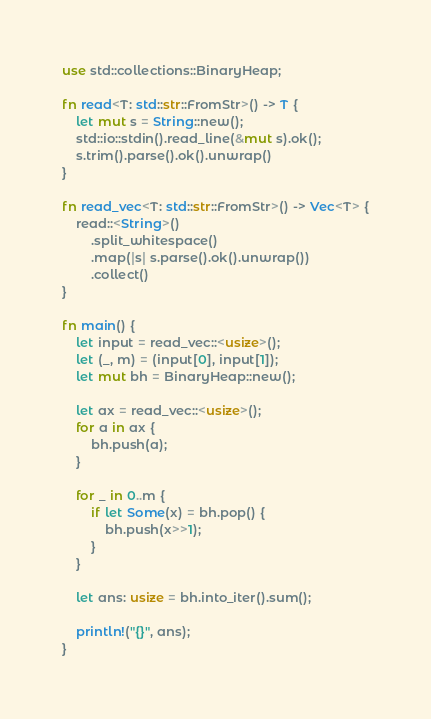<code> <loc_0><loc_0><loc_500><loc_500><_Rust_>use std::collections::BinaryHeap;

fn read<T: std::str::FromStr>() -> T {
    let mut s = String::new();
    std::io::stdin().read_line(&mut s).ok();
    s.trim().parse().ok().unwrap()
}

fn read_vec<T: std::str::FromStr>() -> Vec<T> {
    read::<String>()
        .split_whitespace()
        .map(|s| s.parse().ok().unwrap())
        .collect()
}

fn main() {
    let input = read_vec::<usize>();
    let (_, m) = (input[0], input[1]);
    let mut bh = BinaryHeap::new();

    let ax = read_vec::<usize>();
    for a in ax {
        bh.push(a);
    }

    for _ in 0..m {
        if let Some(x) = bh.pop() {
            bh.push(x>>1);
        }
    }

    let ans: usize = bh.into_iter().sum();

    println!("{}", ans);
}</code> 